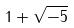Convert formula to latex. <formula><loc_0><loc_0><loc_500><loc_500>1 + \sqrt { - 5 }</formula> 